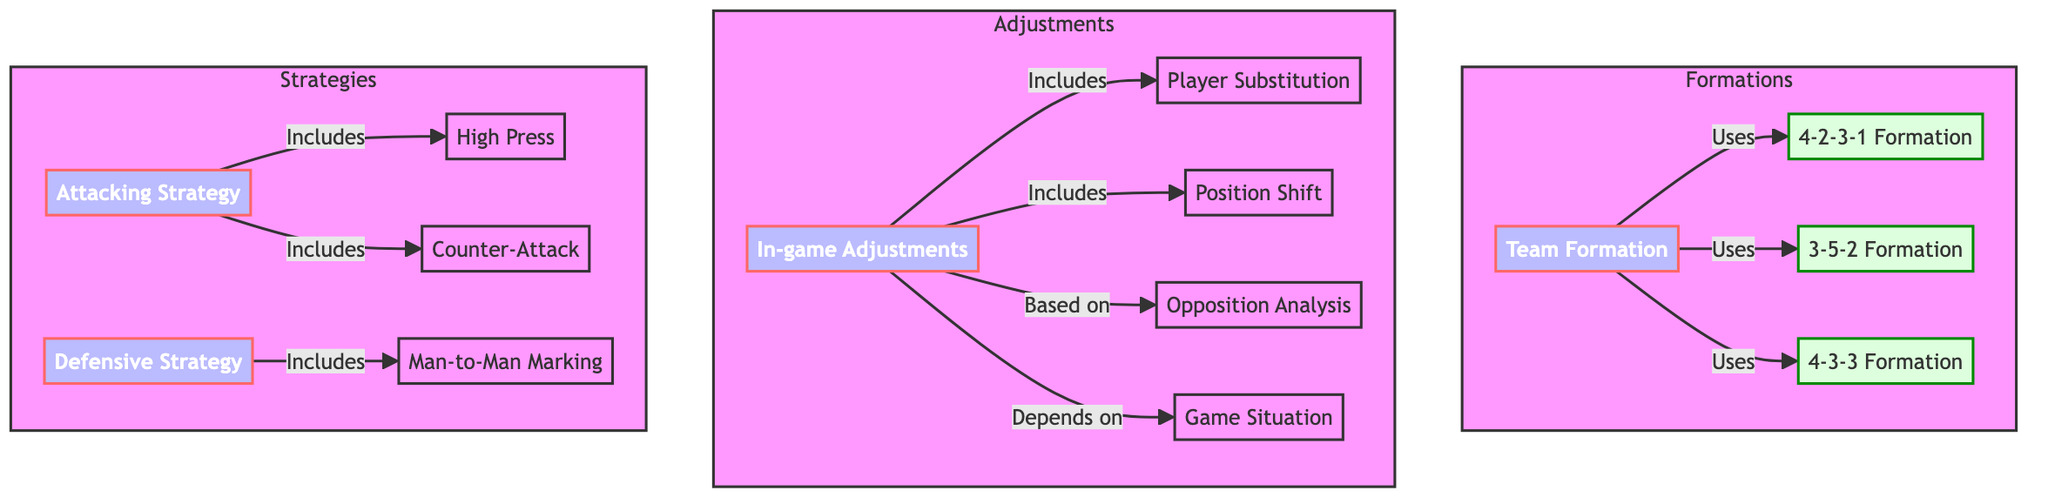What are the three formations used by teams? The diagram indicates that the teams can use the 4-2-3-1, 3-5-2, and 4-3-3 formations. These are represented as direct connections from the "Team Formation" node.
Answer: 4-2-3-1, 3-5-2, 4-3-3 What does "In-game Adjustments" include? The "In-game Adjustments" node has direct connections indicating it includes "Player Substitution" and "Position Shift". Therefore, one can infer that both are parts of the adjustment strategy teams employ during matches.
Answer: Player Substitution, Position Shift How many edges exist in this diagram? By counting the connections between nodes, there are a total of 11 edges represented in the diagram, indicating the various relationships between the different tactical elements.
Answer: 11 What relationship does "Attacking Strategy" have with "High Press" and "Counter-Attack"? The "Attacking Strategy" node has direct connections to both "High Press" and "Counter-Attack", indicating that these are components included within the broader attacking strategies of the teams.
Answer: Includes Which node depends on the "Game Situation"? The diagram shows that "In-game Adjustments" depends on the "Game Situation", as indicated by the directional edge from the "Game Situation" node leading into "In-game Adjustments".
Answer: In-game Adjustments What type of strategy includes "Man-to-Man Marking"? The "Defensive Strategy" node has a direct connection to "Man-to-Man Marking". This indicates that "Man-to-Man Marking" is part of the broader defensive strategies employed by teams.
Answer: Defensive Strategy Which formation is associated with "Team Formation"? The "Team Formation" node uses three formations: 4-2-3-1, 3-5-2, and 4-3-3. All three formations are directly connected to "Team Formation", indicating their usage.
Answer: 4-2-3-1, 3-5-2, 4-3-3 What is the main purpose of "Opposition Analysis"? The "Opposition Analysis" node is linked to "In-game Adjustments", indicating that it serves a key role in informing those adjustments based on the analysis of the opposing team.
Answer: In-game Adjustments 